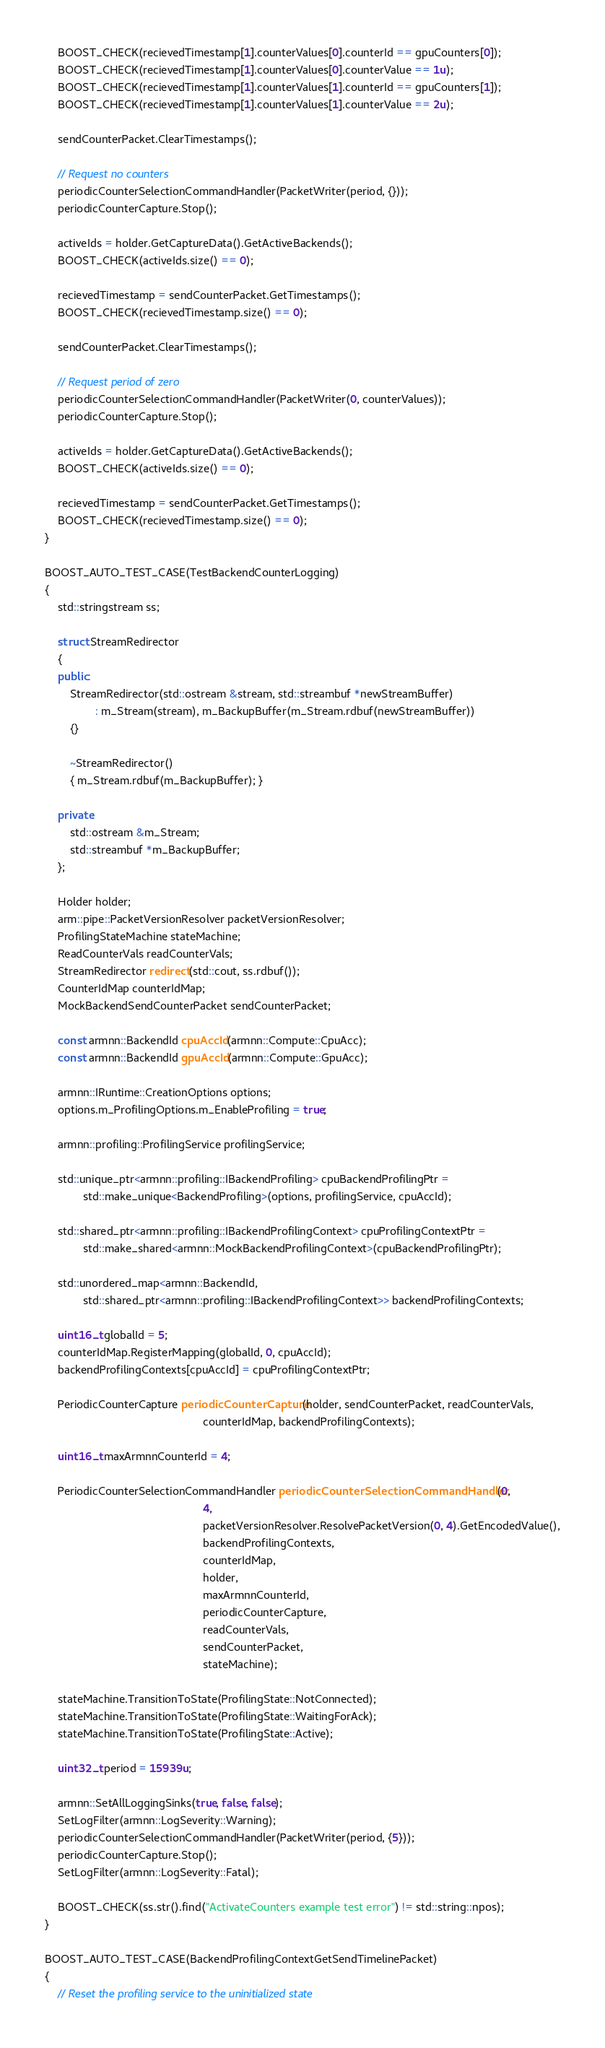Convert code to text. <code><loc_0><loc_0><loc_500><loc_500><_C++_>    BOOST_CHECK(recievedTimestamp[1].counterValues[0].counterId == gpuCounters[0]);
    BOOST_CHECK(recievedTimestamp[1].counterValues[0].counterValue == 1u);
    BOOST_CHECK(recievedTimestamp[1].counterValues[1].counterId == gpuCounters[1]);
    BOOST_CHECK(recievedTimestamp[1].counterValues[1].counterValue == 2u);

    sendCounterPacket.ClearTimestamps();

    // Request no counters
    periodicCounterSelectionCommandHandler(PacketWriter(period, {}));
    periodicCounterCapture.Stop();

    activeIds = holder.GetCaptureData().GetActiveBackends();
    BOOST_CHECK(activeIds.size() == 0);

    recievedTimestamp = sendCounterPacket.GetTimestamps();
    BOOST_CHECK(recievedTimestamp.size() == 0);

    sendCounterPacket.ClearTimestamps();

    // Request period of zero
    periodicCounterSelectionCommandHandler(PacketWriter(0, counterValues));
    periodicCounterCapture.Stop();

    activeIds = holder.GetCaptureData().GetActiveBackends();
    BOOST_CHECK(activeIds.size() == 0);

    recievedTimestamp = sendCounterPacket.GetTimestamps();
    BOOST_CHECK(recievedTimestamp.size() == 0);
}

BOOST_AUTO_TEST_CASE(TestBackendCounterLogging)
{
    std::stringstream ss;

    struct StreamRedirector
    {
    public:
        StreamRedirector(std::ostream &stream, std::streambuf *newStreamBuffer)
                : m_Stream(stream), m_BackupBuffer(m_Stream.rdbuf(newStreamBuffer))
        {}

        ~StreamRedirector()
        { m_Stream.rdbuf(m_BackupBuffer); }

    private:
        std::ostream &m_Stream;
        std::streambuf *m_BackupBuffer;
    };

    Holder holder;
    arm::pipe::PacketVersionResolver packetVersionResolver;
    ProfilingStateMachine stateMachine;
    ReadCounterVals readCounterVals;
    StreamRedirector redirect(std::cout, ss.rdbuf());
    CounterIdMap counterIdMap;
    MockBackendSendCounterPacket sendCounterPacket;

    const armnn::BackendId cpuAccId(armnn::Compute::CpuAcc);
    const armnn::BackendId gpuAccId(armnn::Compute::GpuAcc);

    armnn::IRuntime::CreationOptions options;
    options.m_ProfilingOptions.m_EnableProfiling = true;

    armnn::profiling::ProfilingService profilingService;

    std::unique_ptr<armnn::profiling::IBackendProfiling> cpuBackendProfilingPtr =
            std::make_unique<BackendProfiling>(options, profilingService, cpuAccId);

    std::shared_ptr<armnn::profiling::IBackendProfilingContext> cpuProfilingContextPtr =
            std::make_shared<armnn::MockBackendProfilingContext>(cpuBackendProfilingPtr);

    std::unordered_map<armnn::BackendId,
            std::shared_ptr<armnn::profiling::IBackendProfilingContext>> backendProfilingContexts;

    uint16_t globalId = 5;
    counterIdMap.RegisterMapping(globalId, 0, cpuAccId);
    backendProfilingContexts[cpuAccId] = cpuProfilingContextPtr;

    PeriodicCounterCapture periodicCounterCapture(holder, sendCounterPacket, readCounterVals,
                                                  counterIdMap, backendProfilingContexts);

    uint16_t maxArmnnCounterId = 4;

    PeriodicCounterSelectionCommandHandler periodicCounterSelectionCommandHandler(0,
                                                  4,
                                                  packetVersionResolver.ResolvePacketVersion(0, 4).GetEncodedValue(),
                                                  backendProfilingContexts,
                                                  counterIdMap,
                                                  holder,
                                                  maxArmnnCounterId,
                                                  periodicCounterCapture,
                                                  readCounterVals,
                                                  sendCounterPacket,
                                                  stateMachine);

    stateMachine.TransitionToState(ProfilingState::NotConnected);
    stateMachine.TransitionToState(ProfilingState::WaitingForAck);
    stateMachine.TransitionToState(ProfilingState::Active);

    uint32_t period = 15939u;

    armnn::SetAllLoggingSinks(true, false, false);
    SetLogFilter(armnn::LogSeverity::Warning);
    periodicCounterSelectionCommandHandler(PacketWriter(period, {5}));
    periodicCounterCapture.Stop();
    SetLogFilter(armnn::LogSeverity::Fatal);

    BOOST_CHECK(ss.str().find("ActivateCounters example test error") != std::string::npos);
}

BOOST_AUTO_TEST_CASE(BackendProfilingContextGetSendTimelinePacket)
{
    // Reset the profiling service to the uninitialized state</code> 